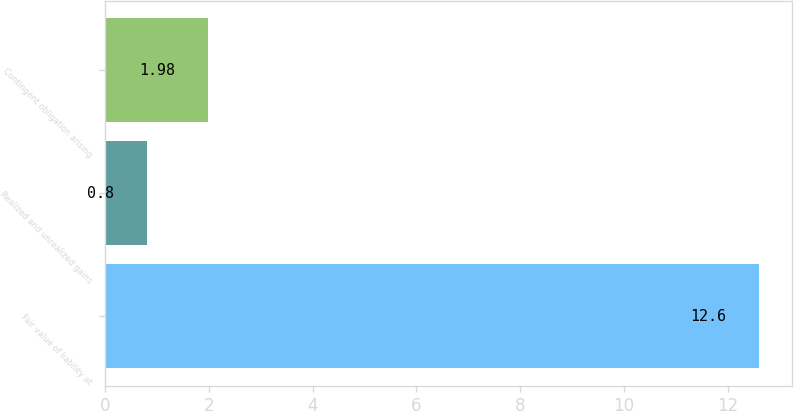Convert chart to OTSL. <chart><loc_0><loc_0><loc_500><loc_500><bar_chart><fcel>Fair value of liability at<fcel>Realized and unrealized gains<fcel>Contingent obligation arising<nl><fcel>12.6<fcel>0.8<fcel>1.98<nl></chart> 